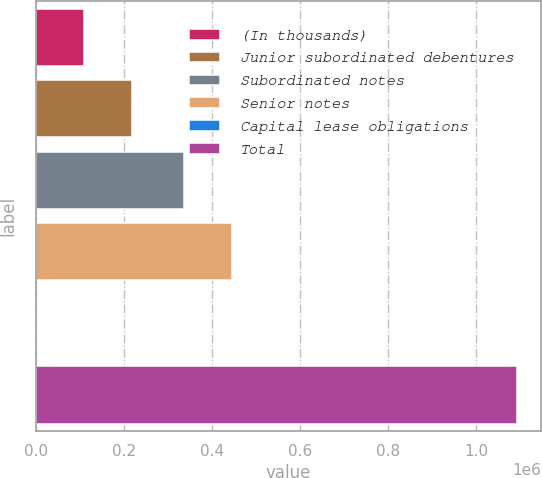Convert chart to OTSL. <chart><loc_0><loc_0><loc_500><loc_500><bar_chart><fcel>(In thousands)<fcel>Junior subordinated debentures<fcel>Subordinated notes<fcel>Senior notes<fcel>Capital lease obligations<fcel>Total<nl><fcel>110184<fcel>219306<fcel>335798<fcel>444920<fcel>1062<fcel>1.09228e+06<nl></chart> 